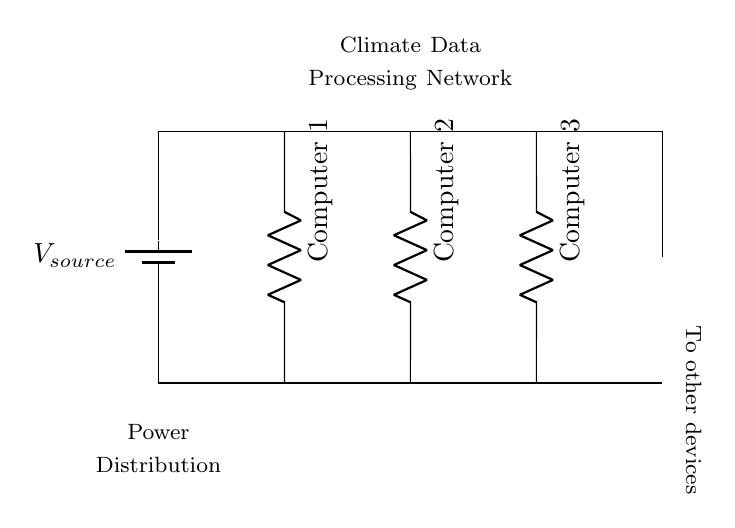What is the type of circuit being used? The circuit is a parallel circuit since the components (computers) are connected across the same two voltage points and each computer has its own path to the power source.
Answer: Parallel How many climate data processing computers are present? The diagram shows three separate computers connected in the circuit, each indicated by a resistor symbol in the parallel configuration.
Answer: Three What is the purpose of the battery in this circuit? The battery provides the voltage source necessary to power the connected devices, in this case, the climate data processing computers.
Answer: Voltage source If one computer fails, how will it affect the other computers? In a parallel circuit, if one component (computer) fails, it does not affect the operation of the other components because each one receives the full voltage from the source independently.
Answer: No effect What does the additional connection point signify? The additional connection point represents a possibility to add more devices to the power distribution system without disrupting the existing computers.
Answer: Additional devices 